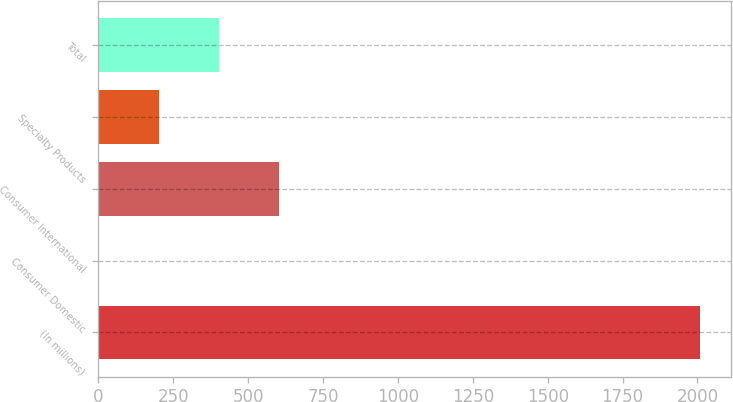Convert chart. <chart><loc_0><loc_0><loc_500><loc_500><bar_chart><fcel>(In millions)<fcel>Consumer Domestic<fcel>Consumer International<fcel>Specialty Products<fcel>Total<nl><fcel>2010<fcel>0.6<fcel>603.42<fcel>201.54<fcel>402.48<nl></chart> 